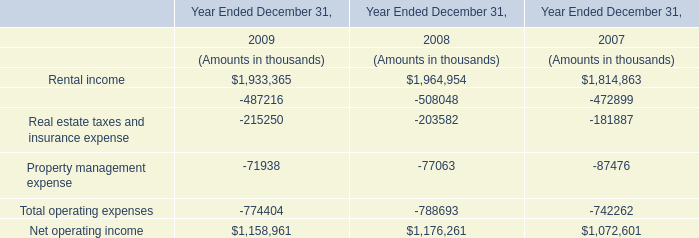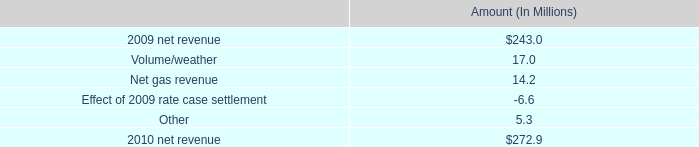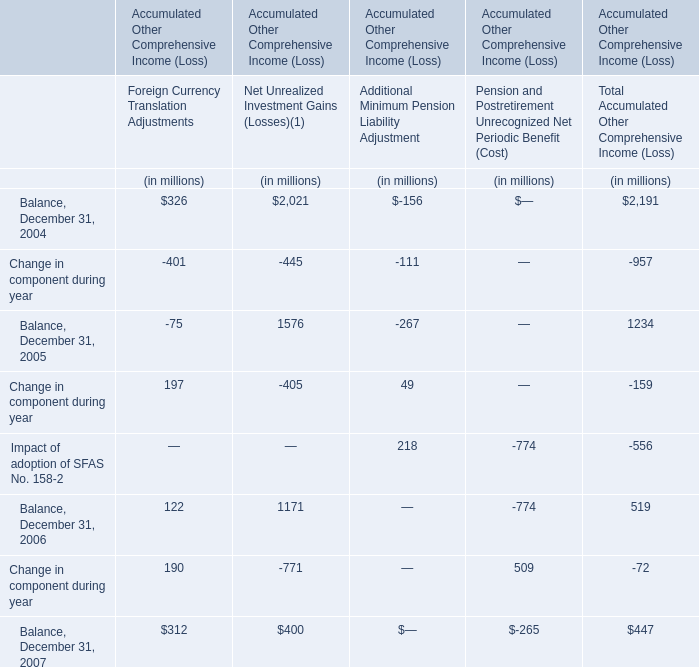What is the difference between 2004 and 2005 's highest Change in component during year? (in million) 
Computations: (-111 + 197)
Answer: 86.0. 